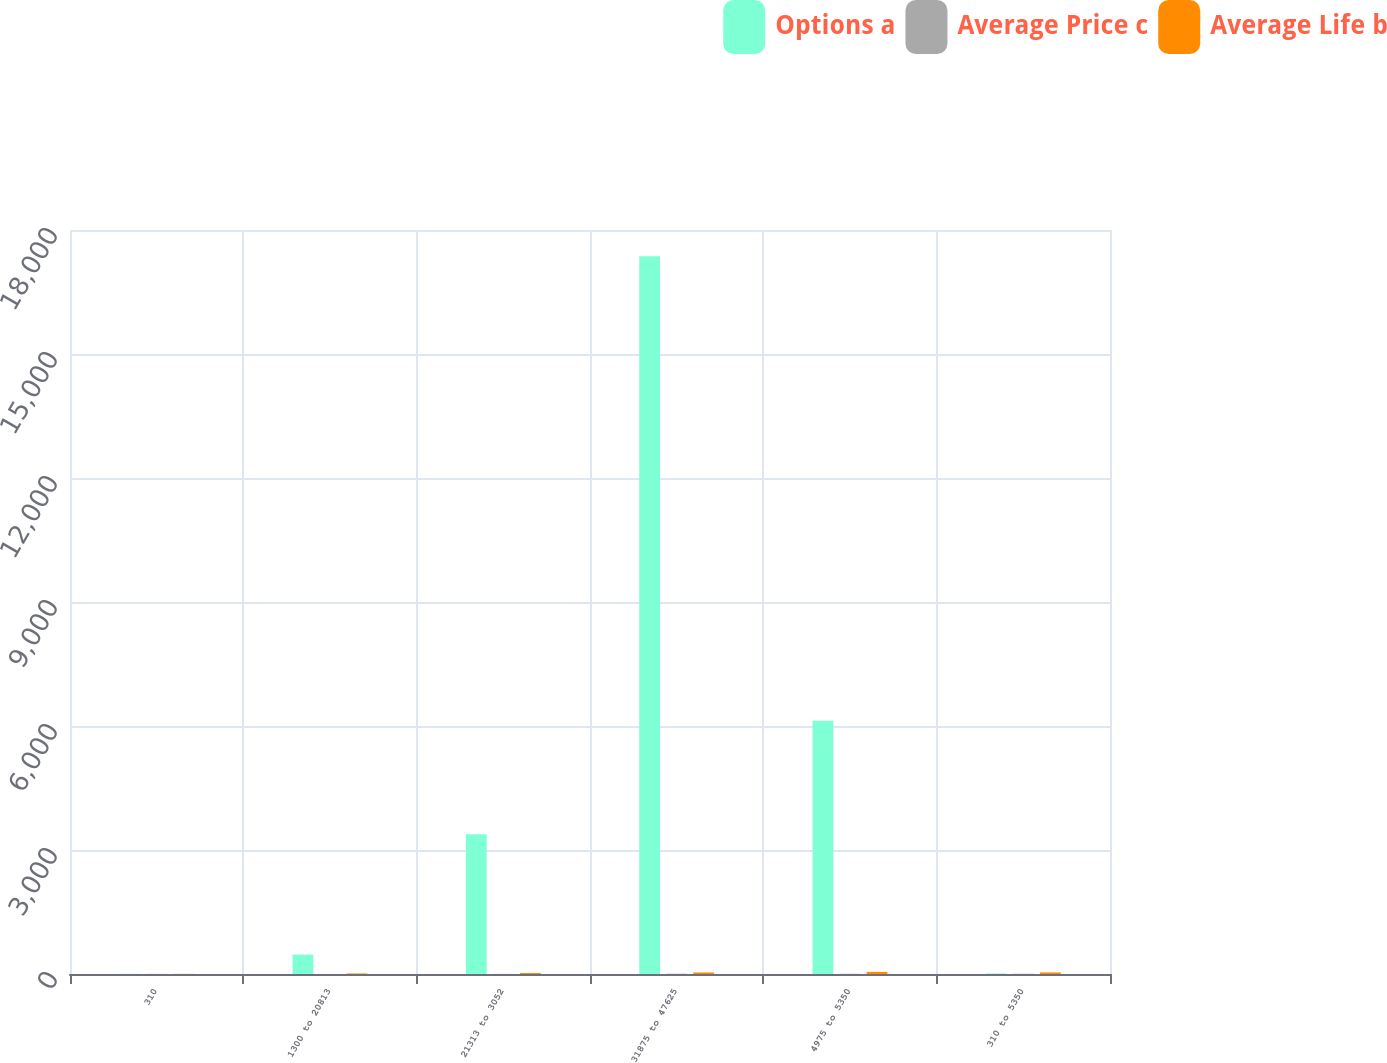Convert chart. <chart><loc_0><loc_0><loc_500><loc_500><stacked_bar_chart><ecel><fcel>310<fcel>1300 to 20813<fcel>21313 to 3052<fcel>31875 to 47625<fcel>4975 to 5350<fcel>310 to 5350<nl><fcel>Options a<fcel>4.1<fcel>469.4<fcel>3383.2<fcel>17363<fcel>6125<fcel>13.13<nl><fcel>Average Price c<fcel>2.3<fcel>0.4<fcel>2.4<fcel>6.4<fcel>4.1<fcel>5.3<nl><fcel>Average Life b<fcel>3.1<fcel>13.13<fcel>24.72<fcel>37.09<fcel>51.71<fcel>38.42<nl></chart> 